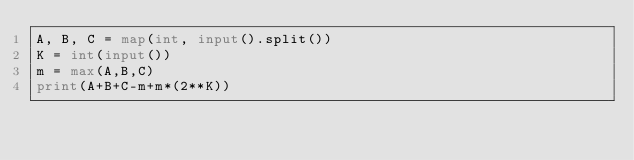<code> <loc_0><loc_0><loc_500><loc_500><_Python_>A, B, C = map(int, input().split())
K = int(input())
m = max(A,B,C)
print(A+B+C-m+m*(2**K))</code> 